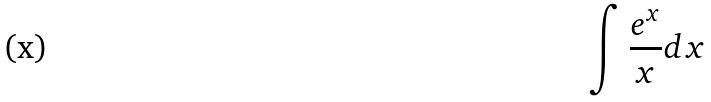<formula> <loc_0><loc_0><loc_500><loc_500>\int \frac { e ^ { x } } { x } d x</formula> 